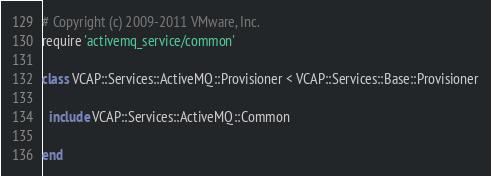<code> <loc_0><loc_0><loc_500><loc_500><_Ruby_># Copyright (c) 2009-2011 VMware, Inc.
require 'activemq_service/common'

class VCAP::Services::ActiveMQ::Provisioner < VCAP::Services::Base::Provisioner

  include VCAP::Services::ActiveMQ::Common

end
</code> 